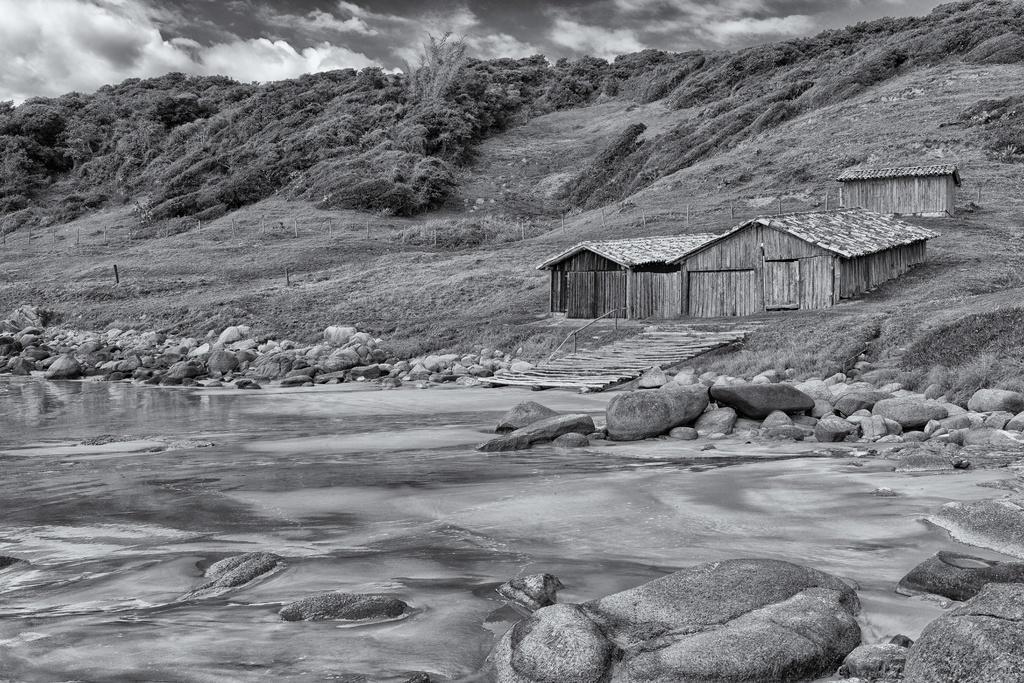Please provide a concise description of this image. In this image, we can see few hits, trees, poles, grass, stones. Here we can see a water is flowing. Top of the image, there is a cloudy sky. 